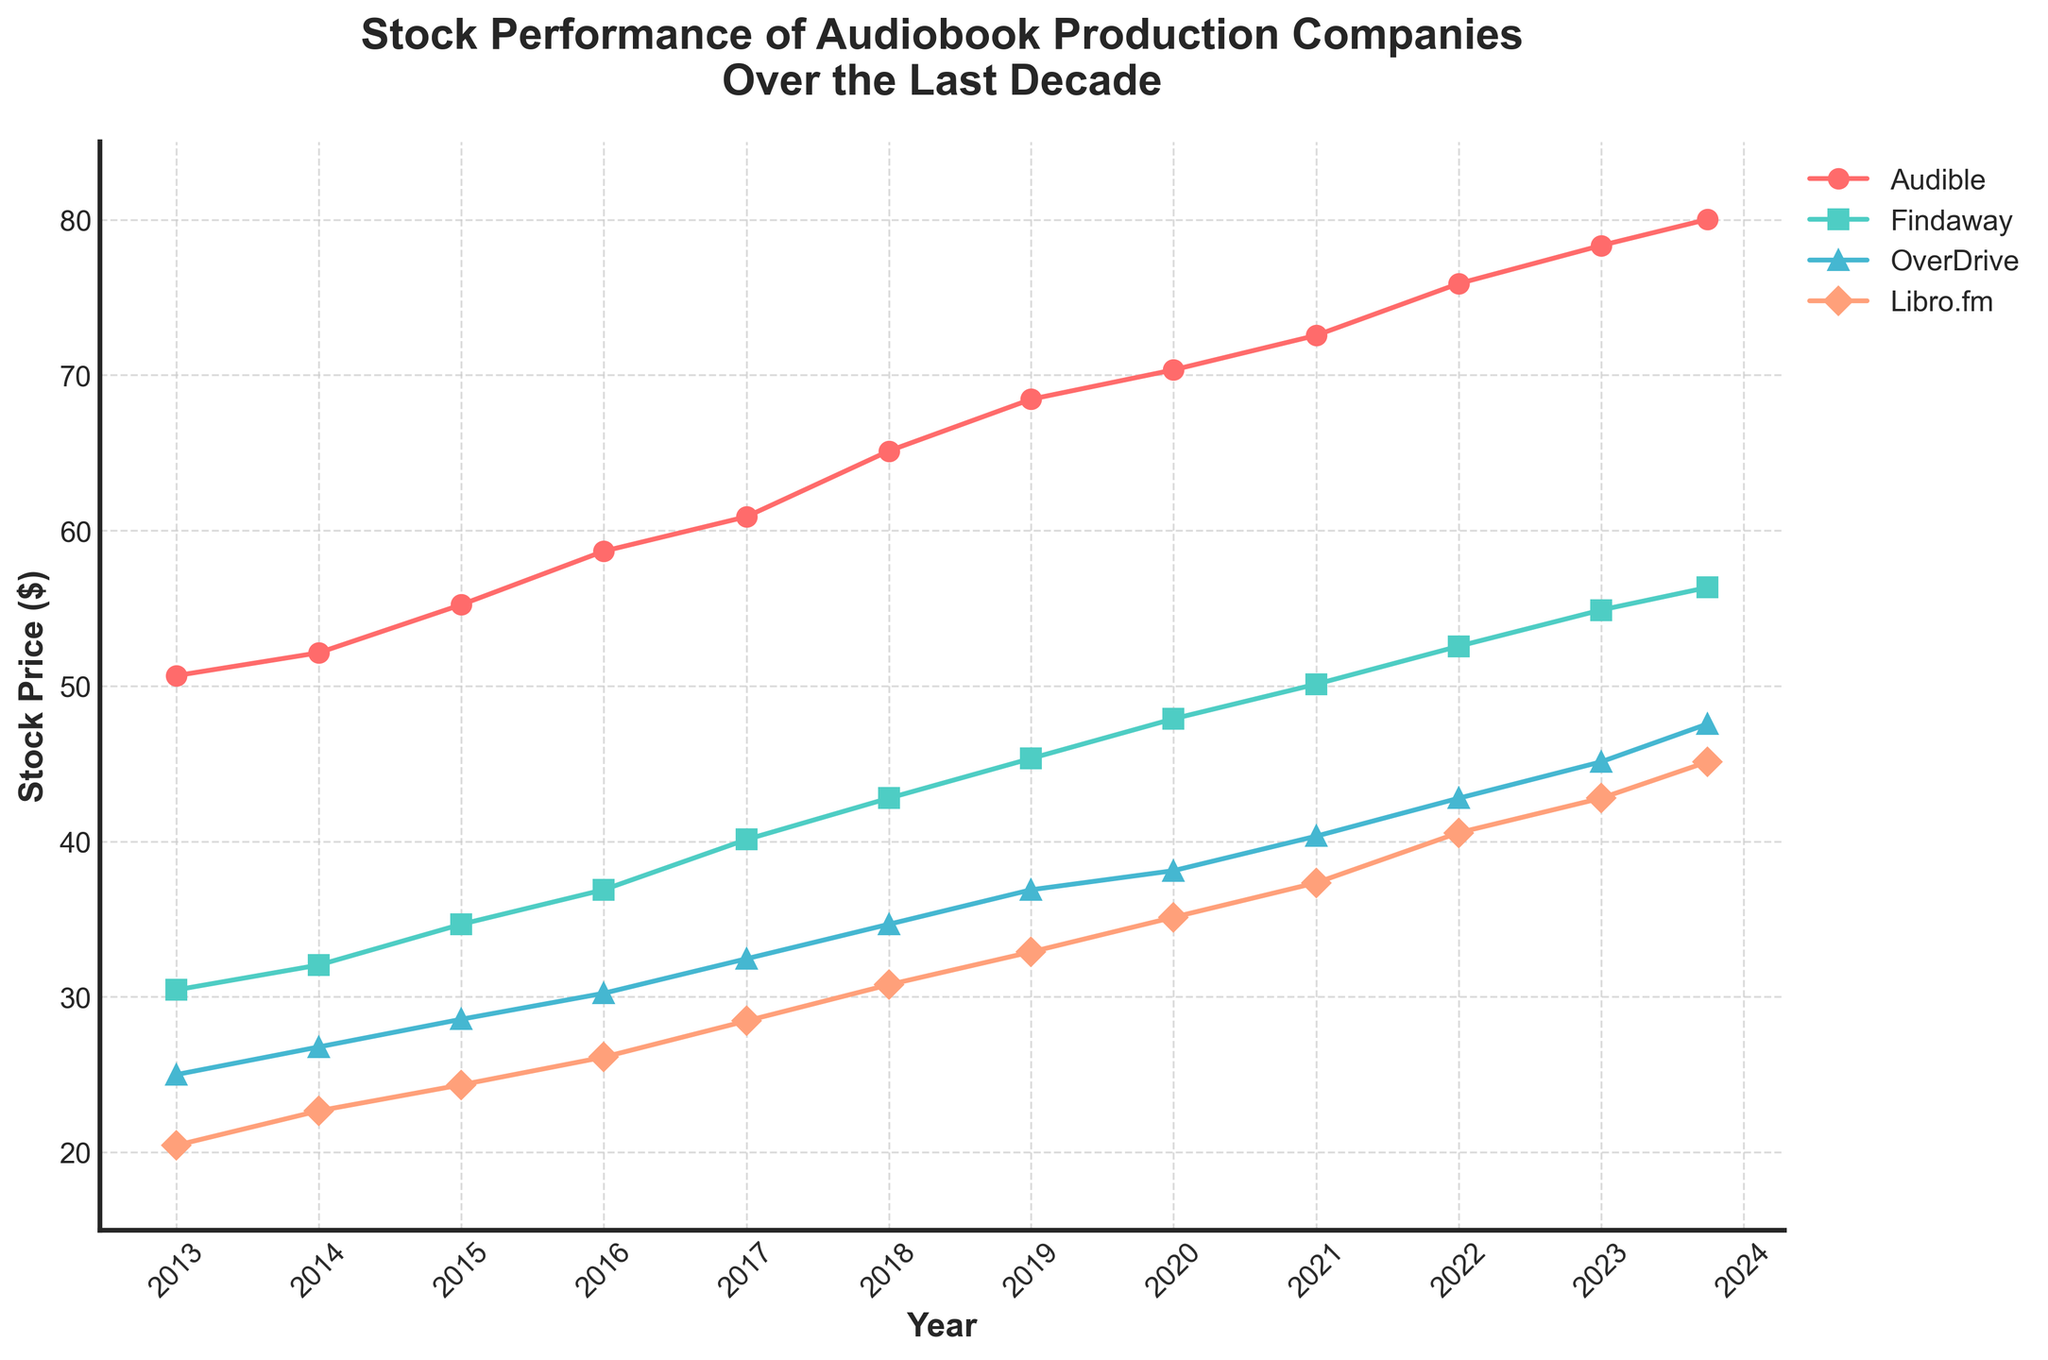How many companies are represented in the figure? The legend in the top right corner indicates the names of the companies. Counting the entries, there are four companies.
Answer: Four What is the title of the figure? The title is located at the top of the figure, usually in larger and bolder font.
Answer: Stock Performance of Audiobook Production Companies Over the Last Decade Which company had the highest stock price at the end of the period shown? By examining the end points of the lines in the plot, Audible has the highest stock price at the final date.
Answer: Audible What was the stock price of OverDrive in 2013? Locate OverDrive in the legend and trace its line back to 2013 on the x-axis, then find the corresponding stock price on the y-axis.
Answer: 25.00 Compare the stock price growth of Audible and Findaway from 2013 to 2023. Which one grew more? Audible's stock price increased from 50.67 to 78.34. Findaway's stock price increased from 30.45 to 54.89. Calculate the growth for both: Audible (78.34 - 50.67 = 27.67), Findaway (54.89 - 30.45 = 24.44).
Answer: Audible Which year showed the largest increase in the stock price for Libro.fm? Find the points on Libro.fm's line in the plot and compare the differences in stock prices year by year. The largest increase is between 2020 (35.12) and 2021 (37.34).
Answer: 2021 What was the average stock price of Findaway in the first five years (2013-2017)? Locate the stock prices of Findaway for the years 2013 to 2017: 30.45, 32.05, 34.67, 36.89, 40.12. Calculate the average: (30.45 + 32.05 + 34.67 + 36.89 + 40.12)/5 = 34.836.
Answer: 34.84 Which company had the smallest increase in stock price over the decade? Compare the initial and final prices of all companies: Audible (27.67), Findaway (24.44), OverDrive (22.56), Libro.fm (24.67). OverDrive has the smallest increase.
Answer: OverDrive Identify the company with the most consistent growth and explain why. Look at the lines in the figure for smoothness and consistency of upward trends. Audible's line is the smoothest with a steady increase, indicating consistent growth.
Answer: Audible By how much did Audible's stock price increase from 2017 to 2023? Audible's stock price in 2017 was 60.89 and in 2023 it was 78.34. Calculate the difference: 78.34 - 60.89 = 17.45.
Answer: 17.45 